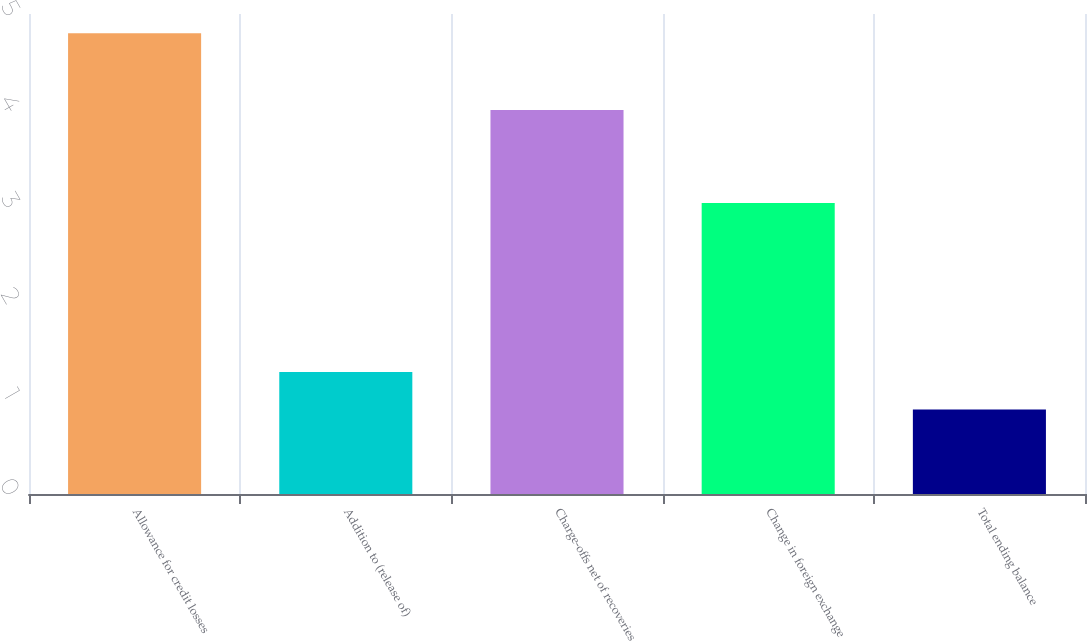Convert chart to OTSL. <chart><loc_0><loc_0><loc_500><loc_500><bar_chart><fcel>Allowance for credit losses<fcel>Addition to (release of)<fcel>Charge-offs net of recoveries<fcel>Change in foreign exchange<fcel>Total ending balance<nl><fcel>4.8<fcel>1.27<fcel>4<fcel>3.03<fcel>0.88<nl></chart> 